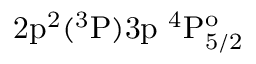Convert formula to latex. <formula><loc_0><loc_0><loc_500><loc_500>2 p ^ { 2 } ( ^ { 3 } P ) 3 p ^ { 4 } P _ { 5 / 2 } ^ { o }</formula> 